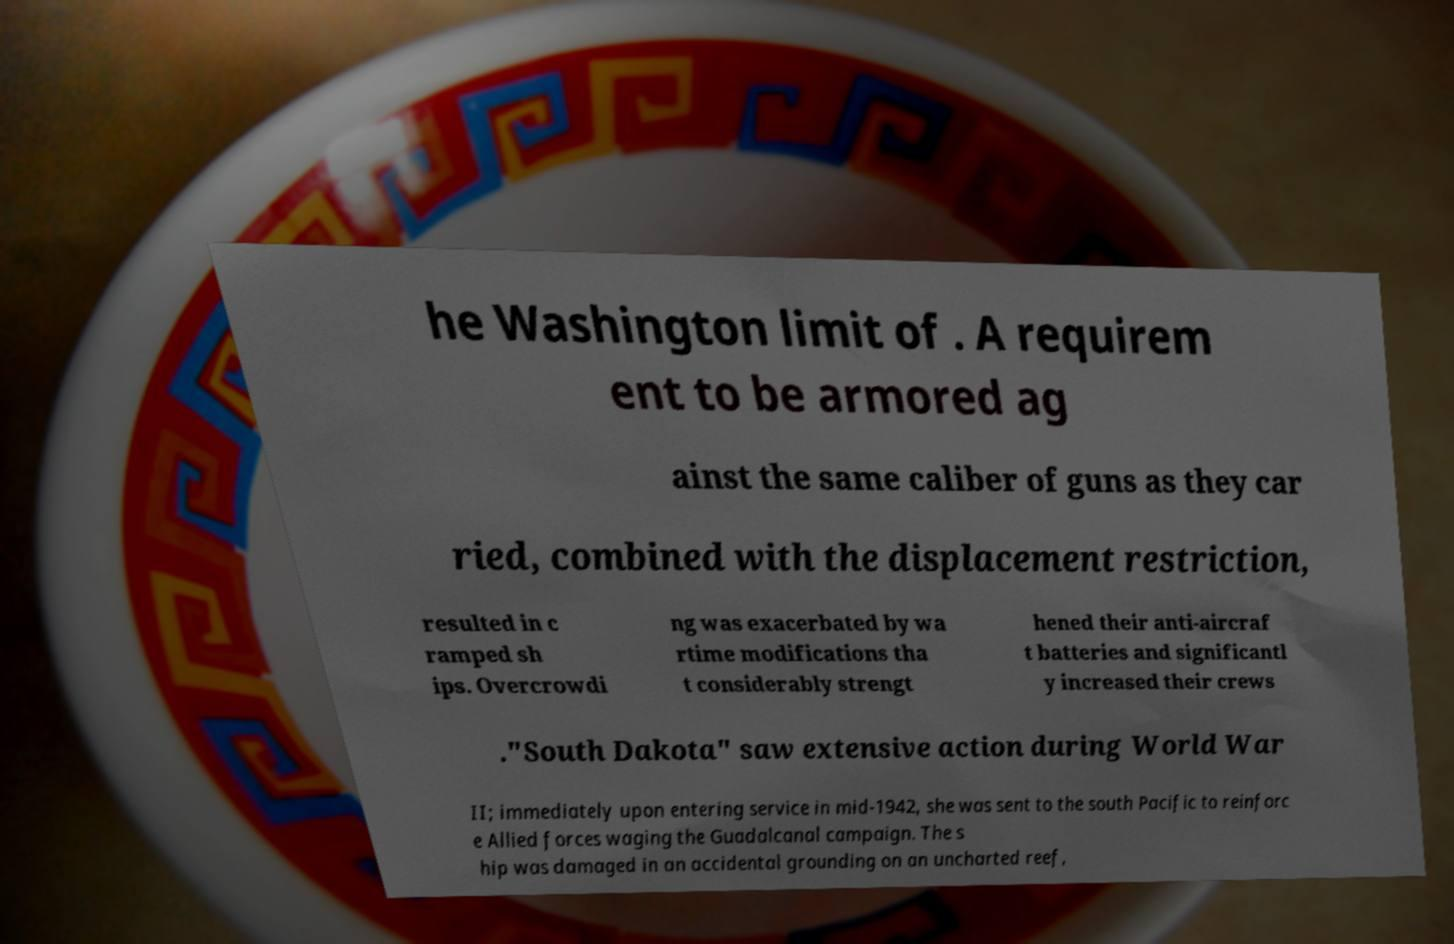What messages or text are displayed in this image? I need them in a readable, typed format. he Washington limit of . A requirem ent to be armored ag ainst the same caliber of guns as they car ried, combined with the displacement restriction, resulted in c ramped sh ips. Overcrowdi ng was exacerbated by wa rtime modifications tha t considerably strengt hened their anti-aircraf t batteries and significantl y increased their crews ."South Dakota" saw extensive action during World War II; immediately upon entering service in mid-1942, she was sent to the south Pacific to reinforc e Allied forces waging the Guadalcanal campaign. The s hip was damaged in an accidental grounding on an uncharted reef, 